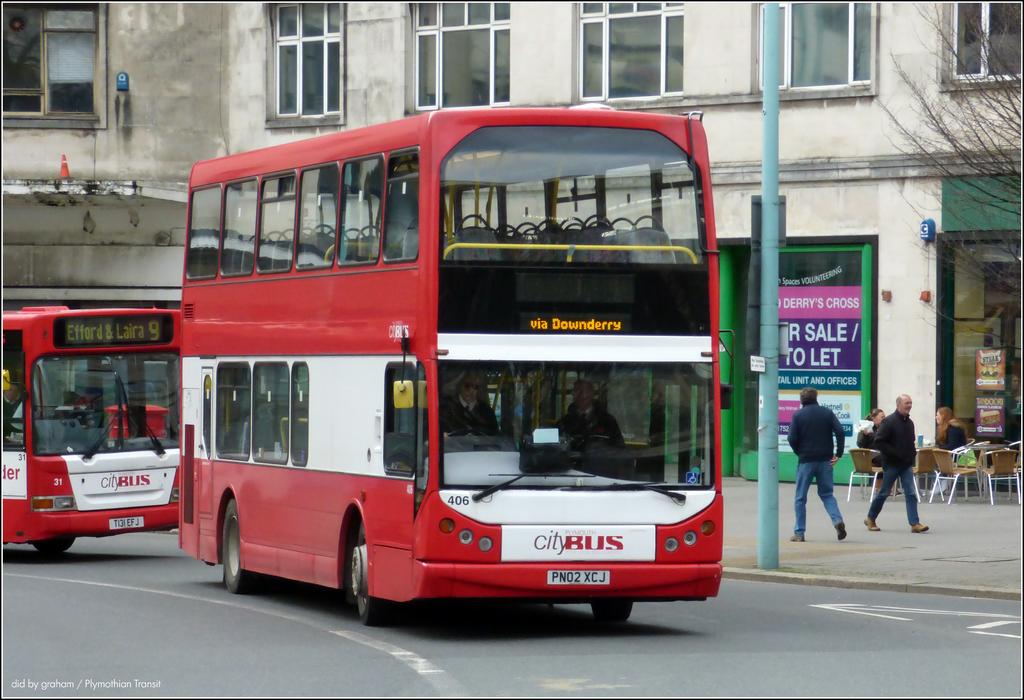What's the purple sign in the window say?
Offer a terse response. For sale/to let. What is the license plate of the double decker bus?
Offer a very short reply. Pn02 xcj. 